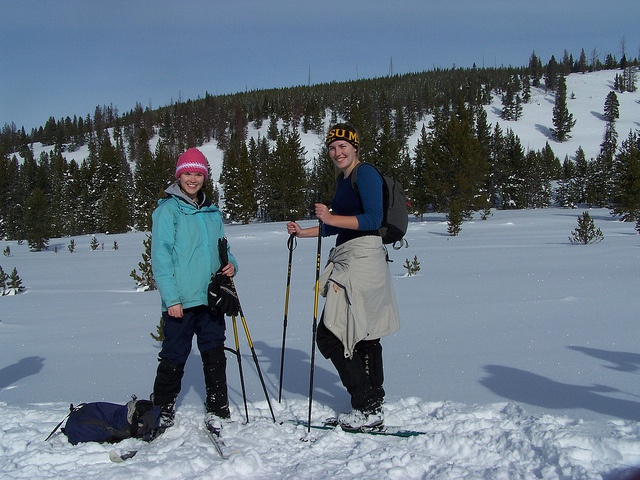Describe the objects in this image and their specific colors. I can see people in gray, black, darkgray, and navy tones, people in gray, black, teal, and brown tones, backpack in gray, black, navy, and darkgray tones, backpack in gray, black, purple, darkgray, and navy tones, and skis in gray, darkgray, black, and blue tones in this image. 